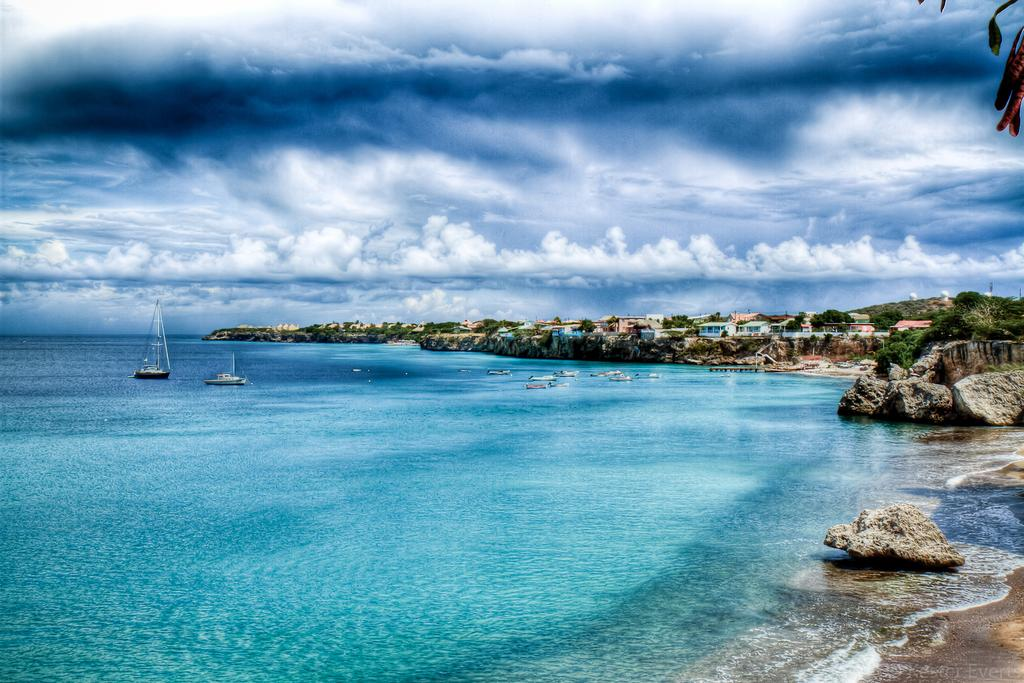What is on the water in the image? There are boats on the water in the image. What other objects or features can be seen in the image? Rocks, houses, and trees are visible in the image. What is visible in the background of the image? The sky with clouds is visible in the background of the image. How many jellyfish can be seen swimming near the boats in the image? There are no jellyfish present in the image; it features boats on the water, rocks, houses, trees, and a sky with clouds in the background. Can you tell me how many train tracks are visible in the image? There are no train tracks present in the image. 